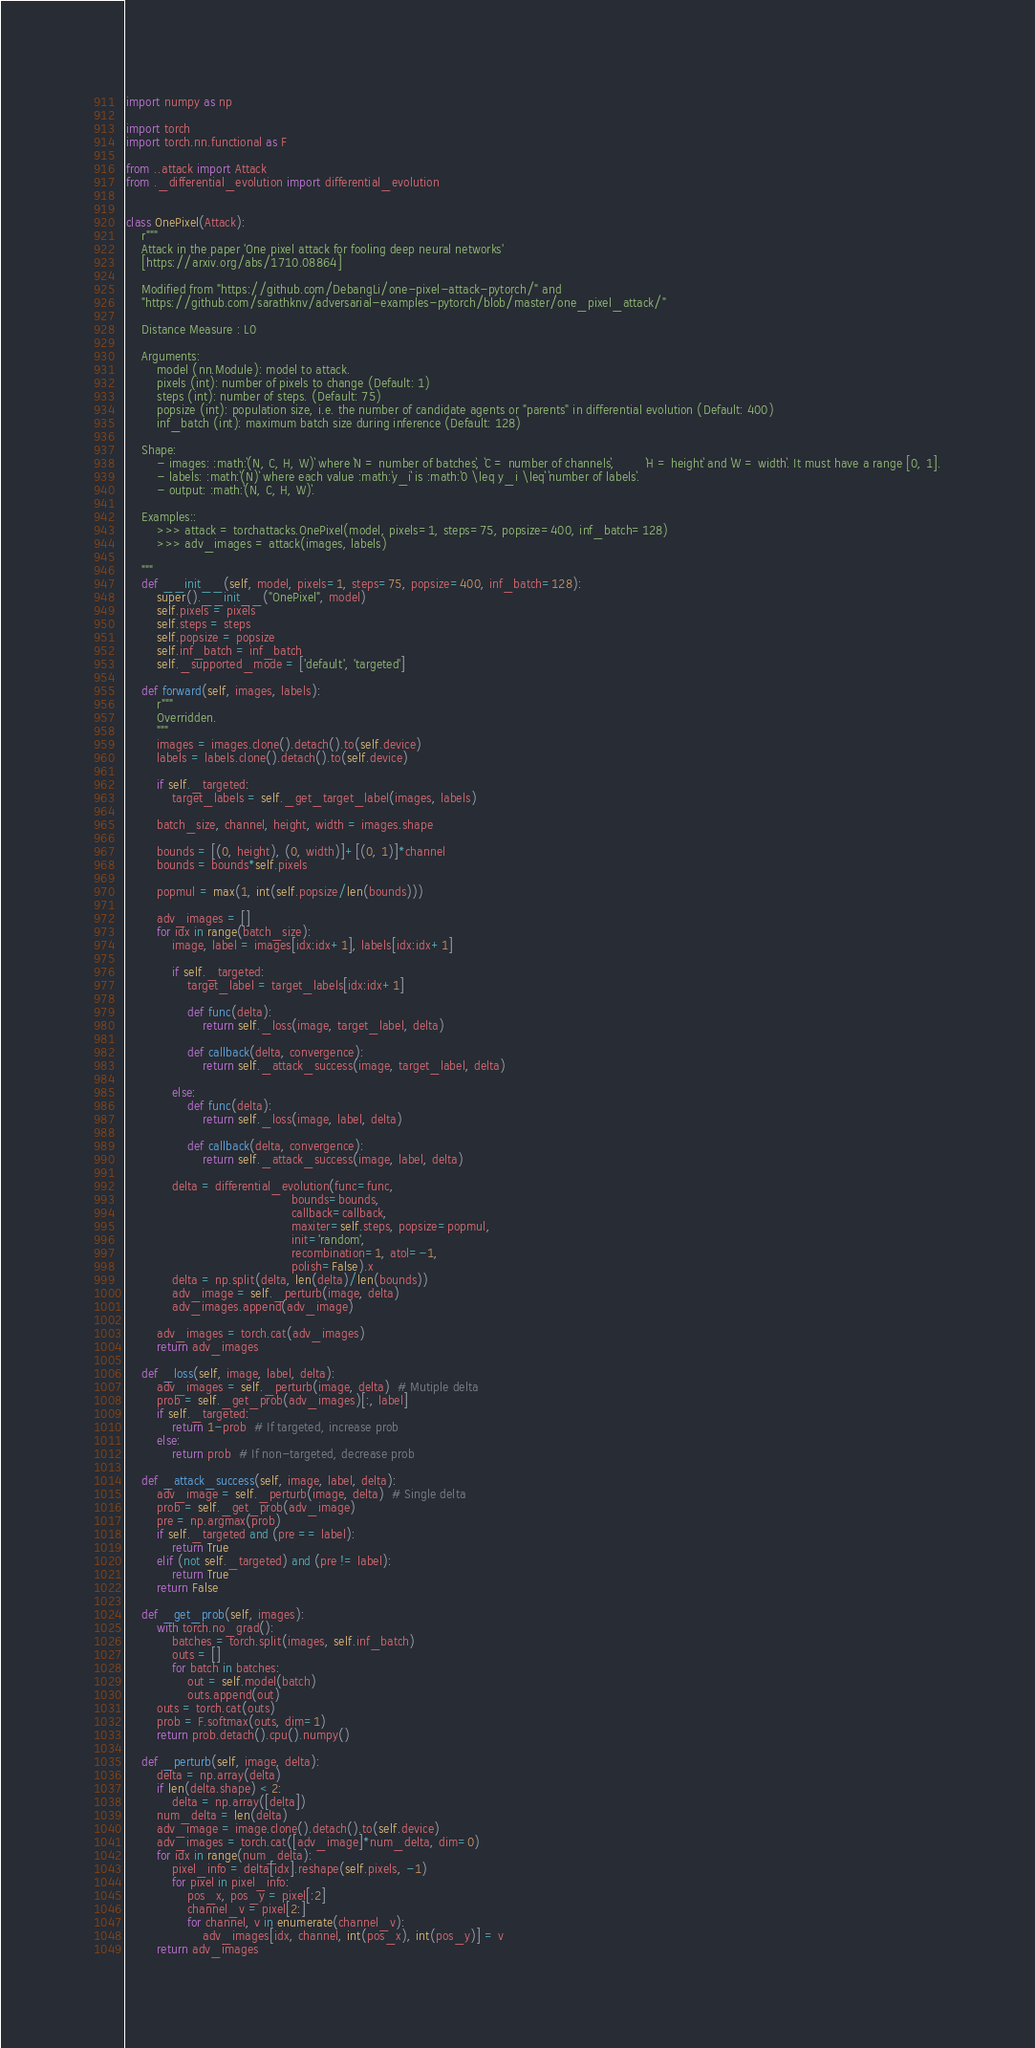<code> <loc_0><loc_0><loc_500><loc_500><_Python_>import numpy as np

import torch
import torch.nn.functional as F

from ..attack import Attack
from ._differential_evolution import differential_evolution


class OnePixel(Attack):
    r"""
    Attack in the paper 'One pixel attack for fooling deep neural networks'
    [https://arxiv.org/abs/1710.08864]

    Modified from "https://github.com/DebangLi/one-pixel-attack-pytorch/" and 
    "https://github.com/sarathknv/adversarial-examples-pytorch/blob/master/one_pixel_attack/"

    Distance Measure : L0

    Arguments:
        model (nn.Module): model to attack.
        pixels (int): number of pixels to change (Default: 1)
        steps (int): number of steps. (Default: 75)
        popsize (int): population size, i.e. the number of candidate agents or "parents" in differential evolution (Default: 400)
        inf_batch (int): maximum batch size during inference (Default: 128)

    Shape:
        - images: :math:`(N, C, H, W)` where `N = number of batches`, `C = number of channels`,        `H = height` and `W = width`. It must have a range [0, 1].
        - labels: :math:`(N)` where each value :math:`y_i` is :math:`0 \leq y_i \leq` `number of labels`.
        - output: :math:`(N, C, H, W)`.

    Examples::
        >>> attack = torchattacks.OnePixel(model, pixels=1, steps=75, popsize=400, inf_batch=128)
        >>> adv_images = attack(images, labels)

    """
    def __init__(self, model, pixels=1, steps=75, popsize=400, inf_batch=128):
        super().__init__("OnePixel", model)
        self.pixels = pixels
        self.steps = steps
        self.popsize = popsize
        self.inf_batch = inf_batch
        self._supported_mode = ['default', 'targeted']

    def forward(self, images, labels):
        r"""
        Overridden.
        """
        images = images.clone().detach().to(self.device)
        labels = labels.clone().detach().to(self.device)

        if self._targeted:
            target_labels = self._get_target_label(images, labels)

        batch_size, channel, height, width = images.shape

        bounds = [(0, height), (0, width)]+[(0, 1)]*channel
        bounds = bounds*self.pixels

        popmul = max(1, int(self.popsize/len(bounds)))

        adv_images = []
        for idx in range(batch_size):
            image, label = images[idx:idx+1], labels[idx:idx+1]

            if self._targeted:
                target_label = target_labels[idx:idx+1]

                def func(delta):
                    return self._loss(image, target_label, delta)

                def callback(delta, convergence):
                    return self._attack_success(image, target_label, delta)

            else:
                def func(delta):
                    return self._loss(image, label, delta)

                def callback(delta, convergence):
                    return self._attack_success(image, label, delta)

            delta = differential_evolution(func=func,
                                           bounds=bounds,
                                           callback=callback,
                                           maxiter=self.steps, popsize=popmul,
                                           init='random',
                                           recombination=1, atol=-1,
                                           polish=False).x
            delta = np.split(delta, len(delta)/len(bounds))
            adv_image = self._perturb(image, delta)
            adv_images.append(adv_image)

        adv_images = torch.cat(adv_images)
        return adv_images

    def _loss(self, image, label, delta):
        adv_images = self._perturb(image, delta)  # Mutiple delta
        prob = self._get_prob(adv_images)[:, label]
        if self._targeted:
            return 1-prob  # If targeted, increase prob
        else:
            return prob  # If non-targeted, decrease prob

    def _attack_success(self, image, label, delta):
        adv_image = self._perturb(image, delta)  # Single delta
        prob = self._get_prob(adv_image)
        pre = np.argmax(prob)
        if self._targeted and (pre == label):
            return True
        elif (not self._targeted) and (pre != label):
            return True
        return False

    def _get_prob(self, images):
        with torch.no_grad():
            batches = torch.split(images, self.inf_batch)
            outs = []
            for batch in batches:
                out = self.model(batch)
                outs.append(out)
        outs = torch.cat(outs)
        prob = F.softmax(outs, dim=1)
        return prob.detach().cpu().numpy()

    def _perturb(self, image, delta):
        delta = np.array(delta)
        if len(delta.shape) < 2:
            delta = np.array([delta])
        num_delta = len(delta)
        adv_image = image.clone().detach().to(self.device)
        adv_images = torch.cat([adv_image]*num_delta, dim=0)
        for idx in range(num_delta):
            pixel_info = delta[idx].reshape(self.pixels, -1)
            for pixel in pixel_info:
                pos_x, pos_y = pixel[:2]
                channel_v = pixel[2:]
                for channel, v in enumerate(channel_v):
                    adv_images[idx, channel, int(pos_x), int(pos_y)] = v
        return adv_images
</code> 